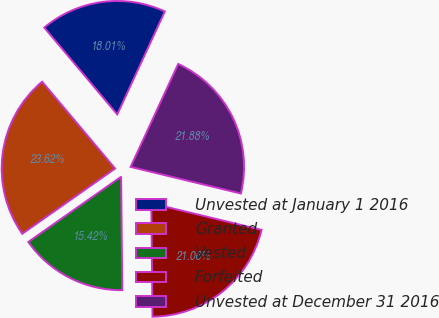Convert chart. <chart><loc_0><loc_0><loc_500><loc_500><pie_chart><fcel>Unvested at January 1 2016<fcel>Granted<fcel>Vested<fcel>Forfeited<fcel>Unvested at December 31 2016<nl><fcel>18.01%<fcel>23.62%<fcel>15.42%<fcel>21.06%<fcel>21.88%<nl></chart> 